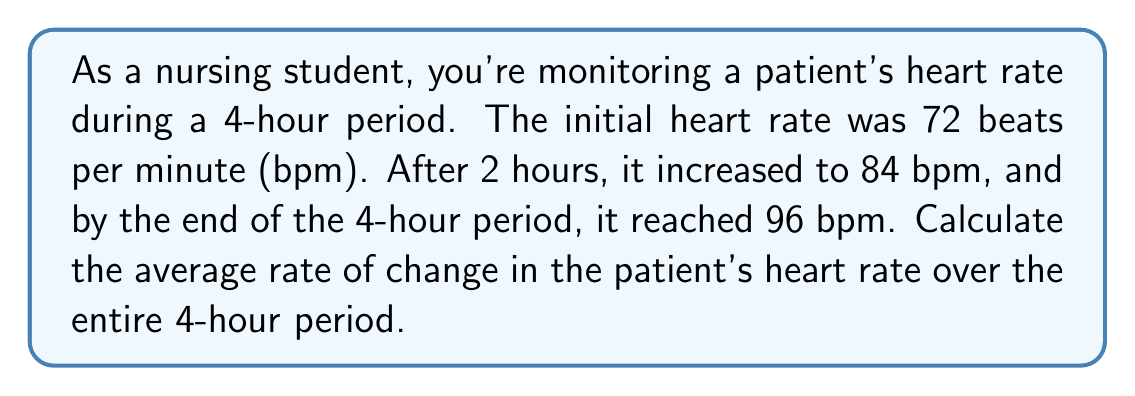Help me with this question. To solve this problem, we need to calculate the average rate of change in the patient's heart rate over the 4-hour period. The rate of change is given by the formula:

$$\text{Rate of Change} = \frac{\text{Change in y}}{\text{Change in x}}$$

Where y represents the heart rate and x represents time.

Let's break down the problem:
1. Initial heart rate: 72 bpm at t = 0 hours
2. Final heart rate: 96 bpm at t = 4 hours

Now, let's apply the formula:

$$\text{Rate of Change} = \frac{\text{Final heart rate - Initial heart rate}}{\text{Final time - Initial time}}$$

$$\text{Rate of Change} = \frac{96 \text{ bpm} - 72 \text{ bpm}}{4 \text{ hours} - 0 \text{ hours}}$$

$$\text{Rate of Change} = \frac{24 \text{ bpm}}{4 \text{ hours}}$$

$$\text{Rate of Change} = 6 \text{ bpm/hour}$$

This means that, on average, the patient's heart rate increased by 6 beats per minute every hour during the 4-hour period.
Answer: The average rate of change in the patient's heart rate over the 4-hour period is 6 bpm/hour. 